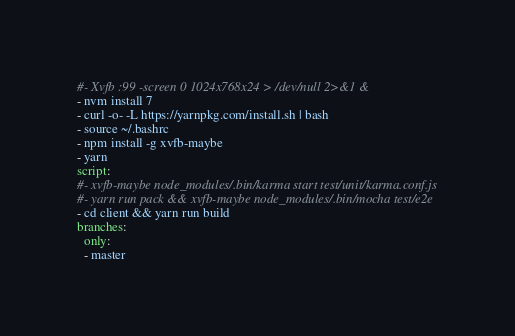Convert code to text. <code><loc_0><loc_0><loc_500><loc_500><_YAML_>#- Xvfb :99 -screen 0 1024x768x24 > /dev/null 2>&1 &
- nvm install 7
- curl -o- -L https://yarnpkg.com/install.sh | bash
- source ~/.bashrc
- npm install -g xvfb-maybe
- yarn
script:
#- xvfb-maybe node_modules/.bin/karma start test/unit/karma.conf.js
#- yarn run pack && xvfb-maybe node_modules/.bin/mocha test/e2e
- cd client && yarn run build
branches:
  only:
  - master
</code> 